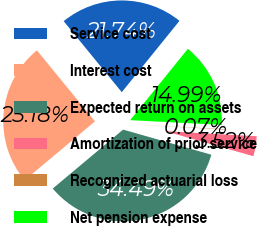Convert chart. <chart><loc_0><loc_0><loc_500><loc_500><pie_chart><fcel>Service cost<fcel>Interest cost<fcel>Expected return on assets<fcel>Amortization of prior service<fcel>Recognized actuarial loss<fcel>Net pension expense<nl><fcel>21.74%<fcel>25.18%<fcel>34.49%<fcel>3.52%<fcel>0.07%<fcel>14.99%<nl></chart> 